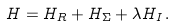<formula> <loc_0><loc_0><loc_500><loc_500>H = H _ { R } + H _ { \Sigma } + \lambda H _ { I } \, .</formula> 